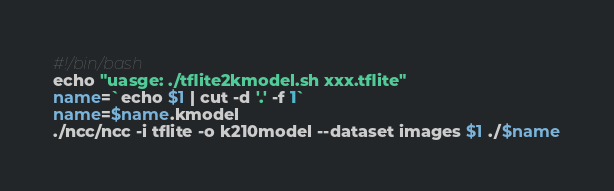Convert code to text. <code><loc_0><loc_0><loc_500><loc_500><_Bash_>#!/bin/bash
echo "uasge: ./tflite2kmodel.sh xxx.tflite"
name=`echo $1 | cut -d '.' -f 1`
name=$name.kmodel
./ncc/ncc -i tflite -o k210model --dataset images $1 ./$name
</code> 